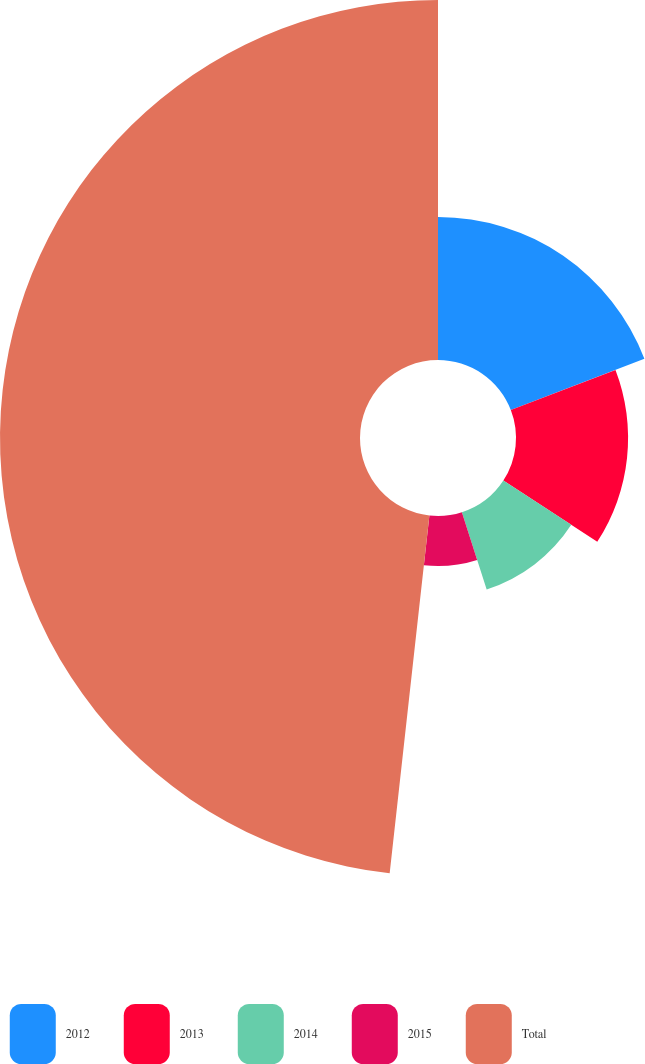Convert chart to OTSL. <chart><loc_0><loc_0><loc_500><loc_500><pie_chart><fcel>2012<fcel>2013<fcel>2014<fcel>2015<fcel>Total<nl><fcel>19.17%<fcel>15.02%<fcel>10.86%<fcel>6.71%<fcel>48.24%<nl></chart> 